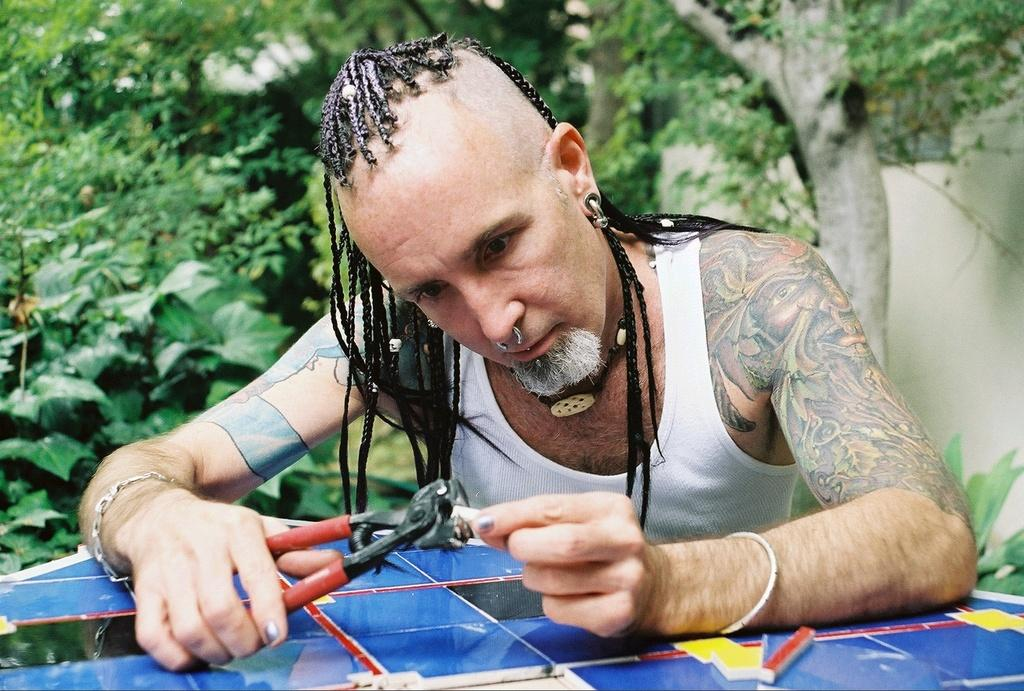What is the main subject of the image? There is a person in the image. What is the person holding in the image? The person is holding cutting pliers. What can be seen in the background of the image? There are trees in the background of the image. What type of stone can be seen in the image? There is no stone present in the image. What color is the orange in the image? There is no orange present in the image. 